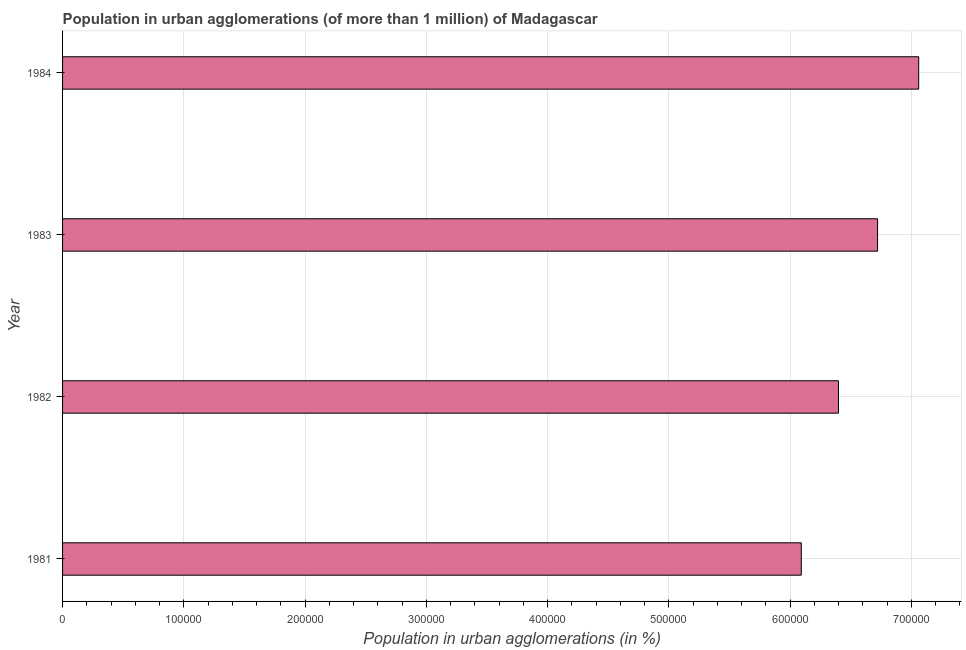Does the graph contain any zero values?
Offer a very short reply. No. What is the title of the graph?
Make the answer very short. Population in urban agglomerations (of more than 1 million) of Madagascar. What is the label or title of the X-axis?
Your response must be concise. Population in urban agglomerations (in %). What is the label or title of the Y-axis?
Your answer should be very brief. Year. What is the population in urban agglomerations in 1982?
Your answer should be very brief. 6.40e+05. Across all years, what is the maximum population in urban agglomerations?
Give a very brief answer. 7.06e+05. Across all years, what is the minimum population in urban agglomerations?
Give a very brief answer. 6.09e+05. In which year was the population in urban agglomerations maximum?
Give a very brief answer. 1984. What is the sum of the population in urban agglomerations?
Your response must be concise. 2.63e+06. What is the difference between the population in urban agglomerations in 1981 and 1983?
Give a very brief answer. -6.29e+04. What is the average population in urban agglomerations per year?
Your response must be concise. 6.57e+05. What is the median population in urban agglomerations?
Provide a succinct answer. 6.56e+05. Do a majority of the years between 1984 and 1983 (inclusive) have population in urban agglomerations greater than 480000 %?
Give a very brief answer. No. Is the population in urban agglomerations in 1983 less than that in 1984?
Provide a short and direct response. Yes. What is the difference between the highest and the second highest population in urban agglomerations?
Make the answer very short. 3.39e+04. Is the sum of the population in urban agglomerations in 1982 and 1984 greater than the maximum population in urban agglomerations across all years?
Make the answer very short. Yes. What is the difference between the highest and the lowest population in urban agglomerations?
Give a very brief answer. 9.68e+04. Are all the bars in the graph horizontal?
Keep it short and to the point. Yes. Are the values on the major ticks of X-axis written in scientific E-notation?
Give a very brief answer. No. What is the Population in urban agglomerations (in %) in 1981?
Provide a succinct answer. 6.09e+05. What is the Population in urban agglomerations (in %) of 1982?
Your response must be concise. 6.40e+05. What is the Population in urban agglomerations (in %) of 1983?
Your response must be concise. 6.72e+05. What is the Population in urban agglomerations (in %) of 1984?
Keep it short and to the point. 7.06e+05. What is the difference between the Population in urban agglomerations (in %) in 1981 and 1982?
Make the answer very short. -3.07e+04. What is the difference between the Population in urban agglomerations (in %) in 1981 and 1983?
Your response must be concise. -6.29e+04. What is the difference between the Population in urban agglomerations (in %) in 1981 and 1984?
Ensure brevity in your answer.  -9.68e+04. What is the difference between the Population in urban agglomerations (in %) in 1982 and 1983?
Your answer should be compact. -3.22e+04. What is the difference between the Population in urban agglomerations (in %) in 1982 and 1984?
Your response must be concise. -6.61e+04. What is the difference between the Population in urban agglomerations (in %) in 1983 and 1984?
Offer a very short reply. -3.39e+04. What is the ratio of the Population in urban agglomerations (in %) in 1981 to that in 1983?
Offer a terse response. 0.91. What is the ratio of the Population in urban agglomerations (in %) in 1981 to that in 1984?
Your response must be concise. 0.86. What is the ratio of the Population in urban agglomerations (in %) in 1982 to that in 1983?
Offer a terse response. 0.95. What is the ratio of the Population in urban agglomerations (in %) in 1982 to that in 1984?
Give a very brief answer. 0.91. What is the ratio of the Population in urban agglomerations (in %) in 1983 to that in 1984?
Your response must be concise. 0.95. 